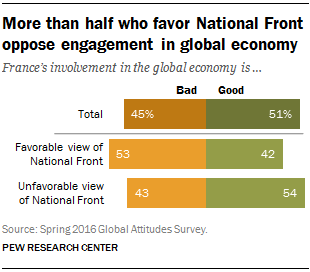Identify some key points in this picture. The highest value in total represents a good outcome. According to the percentage data provided, those who support the National Front are more likely to be in favor of it than those who do not support it, with 11% of the people who favor it being bad and 90% of the people who favor it being good. 